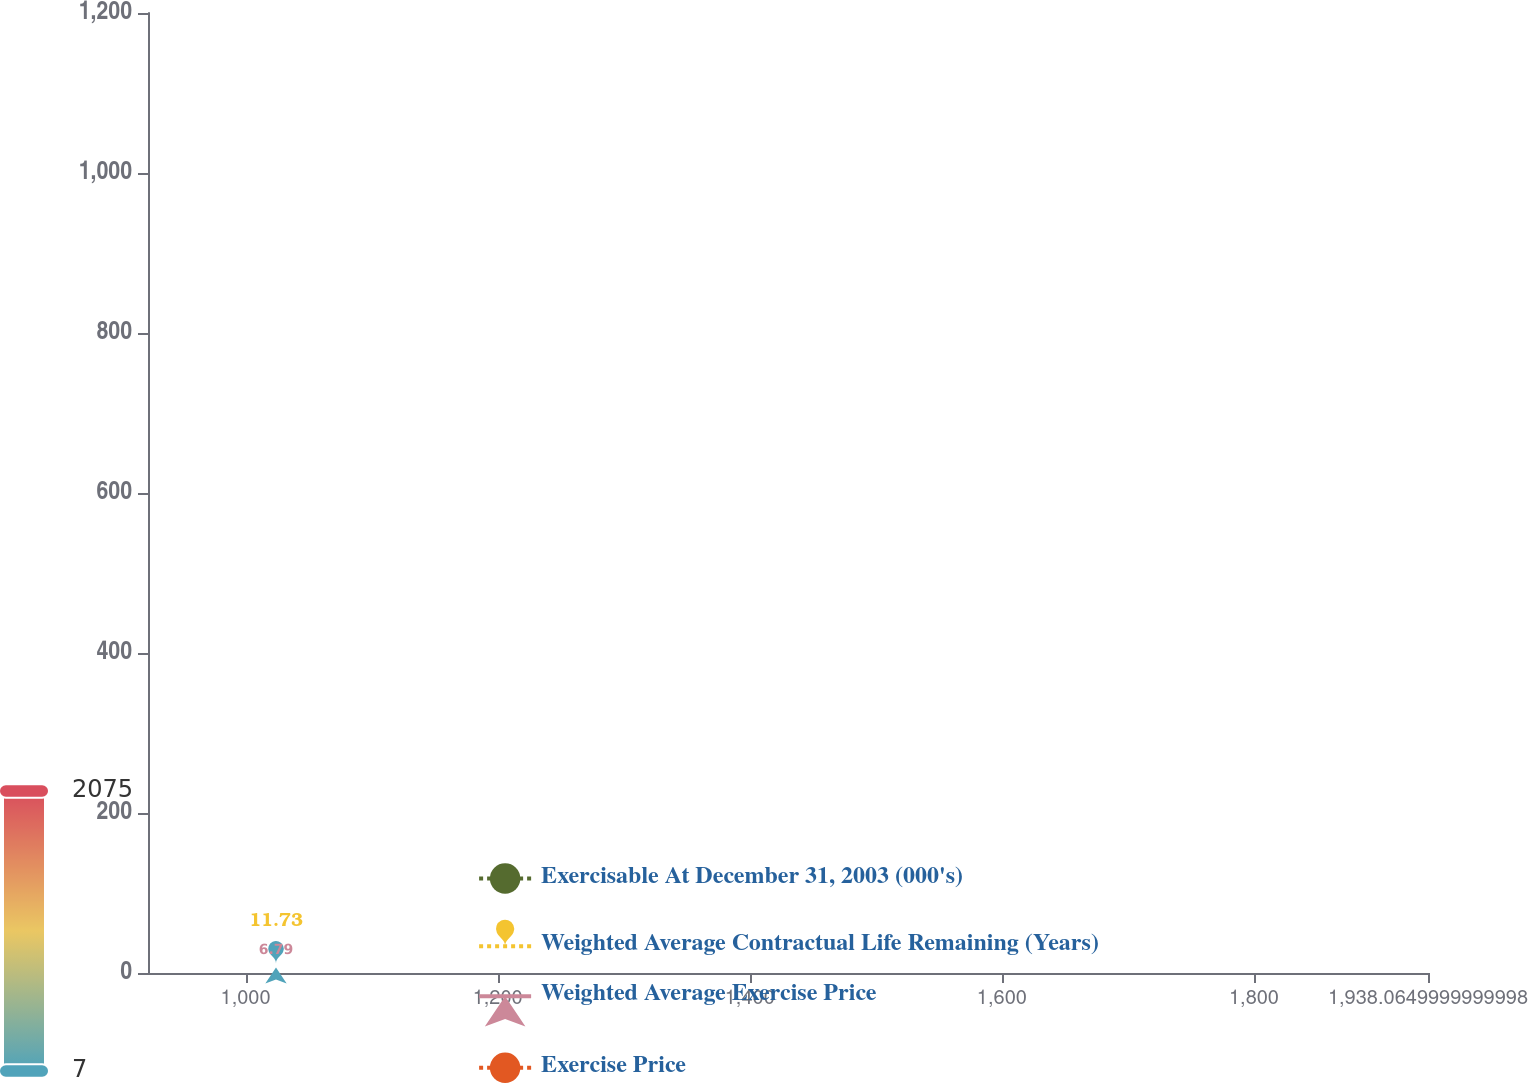Convert chart to OTSL. <chart><loc_0><loc_0><loc_500><loc_500><line_chart><ecel><fcel>Exercisable At December 31, 2003 (000's)<fcel>Weighted Average Contractual Life Remaining (Years)<fcel>Weighted Average Exercise Price<fcel>Exercise Price<nl><fcel>1024.16<fcel>1129.73<fcel>11.73<fcel>6.79<fcel>472.58<nl><fcel>1938.63<fcel>1622.74<fcel>13.86<fcel>7.03<fcel>307.46<nl><fcel>2039.61<fcel>2075.39<fcel>22.46<fcel>9.23<fcel>192.22<nl></chart> 